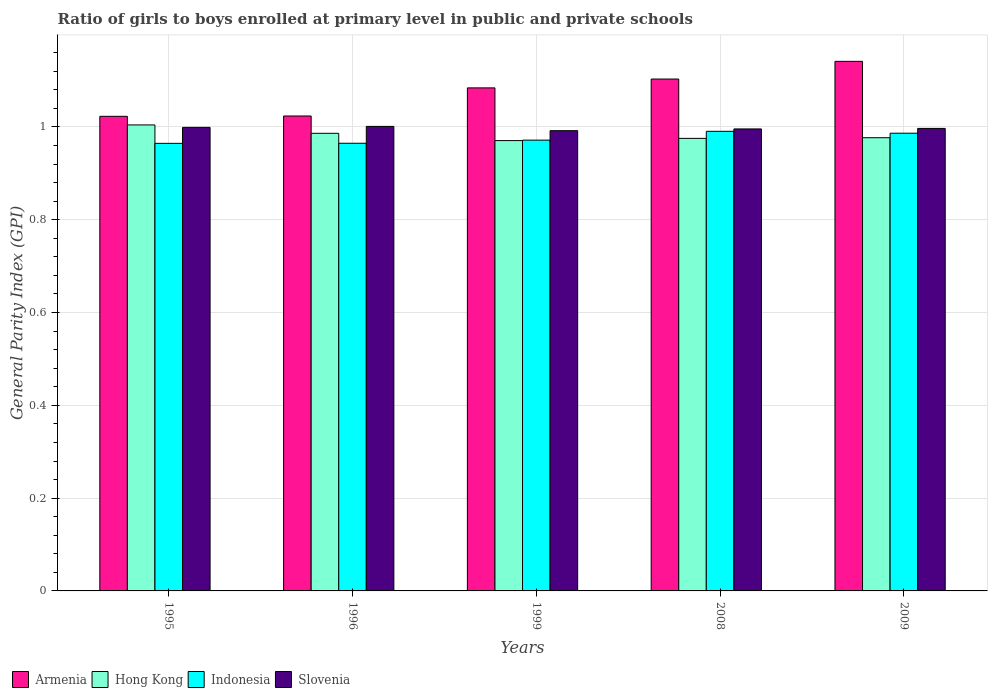How many different coloured bars are there?
Provide a short and direct response. 4. Are the number of bars per tick equal to the number of legend labels?
Your answer should be compact. Yes. How many bars are there on the 2nd tick from the right?
Offer a very short reply. 4. In how many cases, is the number of bars for a given year not equal to the number of legend labels?
Your answer should be very brief. 0. What is the general parity index in Armenia in 1995?
Ensure brevity in your answer.  1.02. Across all years, what is the maximum general parity index in Slovenia?
Make the answer very short. 1. Across all years, what is the minimum general parity index in Armenia?
Your answer should be compact. 1.02. What is the total general parity index in Armenia in the graph?
Keep it short and to the point. 5.38. What is the difference between the general parity index in Slovenia in 1995 and that in 2009?
Offer a very short reply. 0. What is the difference between the general parity index in Slovenia in 2009 and the general parity index in Hong Kong in 1996?
Make the answer very short. 0.01. What is the average general parity index in Slovenia per year?
Make the answer very short. 1. In the year 1995, what is the difference between the general parity index in Hong Kong and general parity index in Armenia?
Your response must be concise. -0.02. What is the ratio of the general parity index in Hong Kong in 1996 to that in 1999?
Make the answer very short. 1.02. Is the difference between the general parity index in Hong Kong in 2008 and 2009 greater than the difference between the general parity index in Armenia in 2008 and 2009?
Your answer should be compact. Yes. What is the difference between the highest and the second highest general parity index in Slovenia?
Your answer should be compact. 0. What is the difference between the highest and the lowest general parity index in Hong Kong?
Provide a succinct answer. 0.03. Is the sum of the general parity index in Indonesia in 1995 and 1996 greater than the maximum general parity index in Hong Kong across all years?
Provide a succinct answer. Yes. What does the 4th bar from the left in 1995 represents?
Your answer should be very brief. Slovenia. How many bars are there?
Keep it short and to the point. 20. How many legend labels are there?
Ensure brevity in your answer.  4. How are the legend labels stacked?
Offer a terse response. Horizontal. What is the title of the graph?
Make the answer very short. Ratio of girls to boys enrolled at primary level in public and private schools. Does "South Asia" appear as one of the legend labels in the graph?
Provide a succinct answer. No. What is the label or title of the X-axis?
Offer a very short reply. Years. What is the label or title of the Y-axis?
Your response must be concise. General Parity Index (GPI). What is the General Parity Index (GPI) in Armenia in 1995?
Offer a terse response. 1.02. What is the General Parity Index (GPI) of Hong Kong in 1995?
Provide a succinct answer. 1. What is the General Parity Index (GPI) in Indonesia in 1995?
Offer a terse response. 0.96. What is the General Parity Index (GPI) of Slovenia in 1995?
Your answer should be very brief. 1. What is the General Parity Index (GPI) in Armenia in 1996?
Make the answer very short. 1.02. What is the General Parity Index (GPI) of Hong Kong in 1996?
Give a very brief answer. 0.99. What is the General Parity Index (GPI) in Indonesia in 1996?
Give a very brief answer. 0.96. What is the General Parity Index (GPI) of Slovenia in 1996?
Your response must be concise. 1. What is the General Parity Index (GPI) in Armenia in 1999?
Keep it short and to the point. 1.08. What is the General Parity Index (GPI) of Hong Kong in 1999?
Provide a succinct answer. 0.97. What is the General Parity Index (GPI) of Indonesia in 1999?
Your response must be concise. 0.97. What is the General Parity Index (GPI) of Slovenia in 1999?
Ensure brevity in your answer.  0.99. What is the General Parity Index (GPI) in Armenia in 2008?
Offer a very short reply. 1.1. What is the General Parity Index (GPI) of Hong Kong in 2008?
Offer a very short reply. 0.98. What is the General Parity Index (GPI) of Indonesia in 2008?
Give a very brief answer. 0.99. What is the General Parity Index (GPI) of Slovenia in 2008?
Keep it short and to the point. 1. What is the General Parity Index (GPI) in Armenia in 2009?
Offer a very short reply. 1.14. What is the General Parity Index (GPI) of Hong Kong in 2009?
Your response must be concise. 0.98. What is the General Parity Index (GPI) in Indonesia in 2009?
Your answer should be compact. 0.99. What is the General Parity Index (GPI) of Slovenia in 2009?
Offer a very short reply. 1. Across all years, what is the maximum General Parity Index (GPI) in Armenia?
Offer a terse response. 1.14. Across all years, what is the maximum General Parity Index (GPI) of Hong Kong?
Give a very brief answer. 1. Across all years, what is the maximum General Parity Index (GPI) of Indonesia?
Provide a succinct answer. 0.99. Across all years, what is the maximum General Parity Index (GPI) in Slovenia?
Offer a very short reply. 1. Across all years, what is the minimum General Parity Index (GPI) in Armenia?
Your answer should be compact. 1.02. Across all years, what is the minimum General Parity Index (GPI) of Hong Kong?
Your answer should be compact. 0.97. Across all years, what is the minimum General Parity Index (GPI) in Indonesia?
Your answer should be compact. 0.96. Across all years, what is the minimum General Parity Index (GPI) of Slovenia?
Provide a succinct answer. 0.99. What is the total General Parity Index (GPI) of Armenia in the graph?
Provide a succinct answer. 5.38. What is the total General Parity Index (GPI) of Hong Kong in the graph?
Offer a terse response. 4.91. What is the total General Parity Index (GPI) in Indonesia in the graph?
Ensure brevity in your answer.  4.88. What is the total General Parity Index (GPI) in Slovenia in the graph?
Your answer should be compact. 4.99. What is the difference between the General Parity Index (GPI) in Armenia in 1995 and that in 1996?
Offer a terse response. -0. What is the difference between the General Parity Index (GPI) in Hong Kong in 1995 and that in 1996?
Provide a succinct answer. 0.02. What is the difference between the General Parity Index (GPI) of Indonesia in 1995 and that in 1996?
Provide a succinct answer. -0. What is the difference between the General Parity Index (GPI) in Slovenia in 1995 and that in 1996?
Provide a succinct answer. -0. What is the difference between the General Parity Index (GPI) in Armenia in 1995 and that in 1999?
Give a very brief answer. -0.06. What is the difference between the General Parity Index (GPI) in Hong Kong in 1995 and that in 1999?
Provide a succinct answer. 0.03. What is the difference between the General Parity Index (GPI) of Indonesia in 1995 and that in 1999?
Your answer should be very brief. -0.01. What is the difference between the General Parity Index (GPI) of Slovenia in 1995 and that in 1999?
Your response must be concise. 0.01. What is the difference between the General Parity Index (GPI) in Armenia in 1995 and that in 2008?
Your response must be concise. -0.08. What is the difference between the General Parity Index (GPI) in Hong Kong in 1995 and that in 2008?
Your answer should be compact. 0.03. What is the difference between the General Parity Index (GPI) in Indonesia in 1995 and that in 2008?
Your answer should be compact. -0.03. What is the difference between the General Parity Index (GPI) of Slovenia in 1995 and that in 2008?
Ensure brevity in your answer.  0. What is the difference between the General Parity Index (GPI) of Armenia in 1995 and that in 2009?
Give a very brief answer. -0.12. What is the difference between the General Parity Index (GPI) of Hong Kong in 1995 and that in 2009?
Offer a very short reply. 0.03. What is the difference between the General Parity Index (GPI) in Indonesia in 1995 and that in 2009?
Give a very brief answer. -0.02. What is the difference between the General Parity Index (GPI) in Slovenia in 1995 and that in 2009?
Give a very brief answer. 0. What is the difference between the General Parity Index (GPI) of Armenia in 1996 and that in 1999?
Keep it short and to the point. -0.06. What is the difference between the General Parity Index (GPI) in Hong Kong in 1996 and that in 1999?
Your answer should be very brief. 0.02. What is the difference between the General Parity Index (GPI) of Indonesia in 1996 and that in 1999?
Your answer should be compact. -0.01. What is the difference between the General Parity Index (GPI) of Slovenia in 1996 and that in 1999?
Offer a terse response. 0.01. What is the difference between the General Parity Index (GPI) in Armenia in 1996 and that in 2008?
Your answer should be very brief. -0.08. What is the difference between the General Parity Index (GPI) in Hong Kong in 1996 and that in 2008?
Keep it short and to the point. 0.01. What is the difference between the General Parity Index (GPI) of Indonesia in 1996 and that in 2008?
Offer a very short reply. -0.03. What is the difference between the General Parity Index (GPI) of Slovenia in 1996 and that in 2008?
Provide a succinct answer. 0.01. What is the difference between the General Parity Index (GPI) of Armenia in 1996 and that in 2009?
Keep it short and to the point. -0.12. What is the difference between the General Parity Index (GPI) in Hong Kong in 1996 and that in 2009?
Your answer should be compact. 0.01. What is the difference between the General Parity Index (GPI) in Indonesia in 1996 and that in 2009?
Your answer should be very brief. -0.02. What is the difference between the General Parity Index (GPI) in Slovenia in 1996 and that in 2009?
Offer a terse response. 0. What is the difference between the General Parity Index (GPI) of Armenia in 1999 and that in 2008?
Ensure brevity in your answer.  -0.02. What is the difference between the General Parity Index (GPI) of Hong Kong in 1999 and that in 2008?
Give a very brief answer. -0. What is the difference between the General Parity Index (GPI) in Indonesia in 1999 and that in 2008?
Your response must be concise. -0.02. What is the difference between the General Parity Index (GPI) of Slovenia in 1999 and that in 2008?
Provide a succinct answer. -0. What is the difference between the General Parity Index (GPI) of Armenia in 1999 and that in 2009?
Offer a terse response. -0.06. What is the difference between the General Parity Index (GPI) of Hong Kong in 1999 and that in 2009?
Your response must be concise. -0.01. What is the difference between the General Parity Index (GPI) of Indonesia in 1999 and that in 2009?
Ensure brevity in your answer.  -0.01. What is the difference between the General Parity Index (GPI) of Slovenia in 1999 and that in 2009?
Your answer should be compact. -0. What is the difference between the General Parity Index (GPI) in Armenia in 2008 and that in 2009?
Provide a short and direct response. -0.04. What is the difference between the General Parity Index (GPI) of Hong Kong in 2008 and that in 2009?
Your answer should be compact. -0. What is the difference between the General Parity Index (GPI) in Indonesia in 2008 and that in 2009?
Provide a short and direct response. 0. What is the difference between the General Parity Index (GPI) of Slovenia in 2008 and that in 2009?
Provide a succinct answer. -0. What is the difference between the General Parity Index (GPI) in Armenia in 1995 and the General Parity Index (GPI) in Hong Kong in 1996?
Offer a very short reply. 0.04. What is the difference between the General Parity Index (GPI) in Armenia in 1995 and the General Parity Index (GPI) in Indonesia in 1996?
Provide a short and direct response. 0.06. What is the difference between the General Parity Index (GPI) in Armenia in 1995 and the General Parity Index (GPI) in Slovenia in 1996?
Ensure brevity in your answer.  0.02. What is the difference between the General Parity Index (GPI) of Hong Kong in 1995 and the General Parity Index (GPI) of Indonesia in 1996?
Keep it short and to the point. 0.04. What is the difference between the General Parity Index (GPI) of Hong Kong in 1995 and the General Parity Index (GPI) of Slovenia in 1996?
Give a very brief answer. 0. What is the difference between the General Parity Index (GPI) in Indonesia in 1995 and the General Parity Index (GPI) in Slovenia in 1996?
Provide a succinct answer. -0.04. What is the difference between the General Parity Index (GPI) in Armenia in 1995 and the General Parity Index (GPI) in Hong Kong in 1999?
Offer a very short reply. 0.05. What is the difference between the General Parity Index (GPI) of Armenia in 1995 and the General Parity Index (GPI) of Indonesia in 1999?
Offer a very short reply. 0.05. What is the difference between the General Parity Index (GPI) of Armenia in 1995 and the General Parity Index (GPI) of Slovenia in 1999?
Provide a short and direct response. 0.03. What is the difference between the General Parity Index (GPI) in Hong Kong in 1995 and the General Parity Index (GPI) in Indonesia in 1999?
Your answer should be compact. 0.03. What is the difference between the General Parity Index (GPI) of Hong Kong in 1995 and the General Parity Index (GPI) of Slovenia in 1999?
Your answer should be very brief. 0.01. What is the difference between the General Parity Index (GPI) of Indonesia in 1995 and the General Parity Index (GPI) of Slovenia in 1999?
Make the answer very short. -0.03. What is the difference between the General Parity Index (GPI) in Armenia in 1995 and the General Parity Index (GPI) in Hong Kong in 2008?
Offer a terse response. 0.05. What is the difference between the General Parity Index (GPI) in Armenia in 1995 and the General Parity Index (GPI) in Indonesia in 2008?
Your answer should be very brief. 0.03. What is the difference between the General Parity Index (GPI) in Armenia in 1995 and the General Parity Index (GPI) in Slovenia in 2008?
Give a very brief answer. 0.03. What is the difference between the General Parity Index (GPI) in Hong Kong in 1995 and the General Parity Index (GPI) in Indonesia in 2008?
Keep it short and to the point. 0.01. What is the difference between the General Parity Index (GPI) in Hong Kong in 1995 and the General Parity Index (GPI) in Slovenia in 2008?
Make the answer very short. 0.01. What is the difference between the General Parity Index (GPI) in Indonesia in 1995 and the General Parity Index (GPI) in Slovenia in 2008?
Make the answer very short. -0.03. What is the difference between the General Parity Index (GPI) in Armenia in 1995 and the General Parity Index (GPI) in Hong Kong in 2009?
Provide a succinct answer. 0.05. What is the difference between the General Parity Index (GPI) of Armenia in 1995 and the General Parity Index (GPI) of Indonesia in 2009?
Offer a very short reply. 0.04. What is the difference between the General Parity Index (GPI) of Armenia in 1995 and the General Parity Index (GPI) of Slovenia in 2009?
Offer a terse response. 0.03. What is the difference between the General Parity Index (GPI) in Hong Kong in 1995 and the General Parity Index (GPI) in Indonesia in 2009?
Provide a succinct answer. 0.02. What is the difference between the General Parity Index (GPI) of Hong Kong in 1995 and the General Parity Index (GPI) of Slovenia in 2009?
Provide a short and direct response. 0.01. What is the difference between the General Parity Index (GPI) of Indonesia in 1995 and the General Parity Index (GPI) of Slovenia in 2009?
Keep it short and to the point. -0.03. What is the difference between the General Parity Index (GPI) of Armenia in 1996 and the General Parity Index (GPI) of Hong Kong in 1999?
Ensure brevity in your answer.  0.05. What is the difference between the General Parity Index (GPI) of Armenia in 1996 and the General Parity Index (GPI) of Indonesia in 1999?
Give a very brief answer. 0.05. What is the difference between the General Parity Index (GPI) in Armenia in 1996 and the General Parity Index (GPI) in Slovenia in 1999?
Keep it short and to the point. 0.03. What is the difference between the General Parity Index (GPI) in Hong Kong in 1996 and the General Parity Index (GPI) in Indonesia in 1999?
Make the answer very short. 0.01. What is the difference between the General Parity Index (GPI) in Hong Kong in 1996 and the General Parity Index (GPI) in Slovenia in 1999?
Provide a short and direct response. -0.01. What is the difference between the General Parity Index (GPI) of Indonesia in 1996 and the General Parity Index (GPI) of Slovenia in 1999?
Your answer should be very brief. -0.03. What is the difference between the General Parity Index (GPI) of Armenia in 1996 and the General Parity Index (GPI) of Hong Kong in 2008?
Ensure brevity in your answer.  0.05. What is the difference between the General Parity Index (GPI) in Armenia in 1996 and the General Parity Index (GPI) in Indonesia in 2008?
Offer a terse response. 0.03. What is the difference between the General Parity Index (GPI) of Armenia in 1996 and the General Parity Index (GPI) of Slovenia in 2008?
Give a very brief answer. 0.03. What is the difference between the General Parity Index (GPI) in Hong Kong in 1996 and the General Parity Index (GPI) in Indonesia in 2008?
Provide a short and direct response. -0. What is the difference between the General Parity Index (GPI) in Hong Kong in 1996 and the General Parity Index (GPI) in Slovenia in 2008?
Offer a terse response. -0.01. What is the difference between the General Parity Index (GPI) of Indonesia in 1996 and the General Parity Index (GPI) of Slovenia in 2008?
Give a very brief answer. -0.03. What is the difference between the General Parity Index (GPI) of Armenia in 1996 and the General Parity Index (GPI) of Hong Kong in 2009?
Offer a terse response. 0.05. What is the difference between the General Parity Index (GPI) in Armenia in 1996 and the General Parity Index (GPI) in Indonesia in 2009?
Your response must be concise. 0.04. What is the difference between the General Parity Index (GPI) in Armenia in 1996 and the General Parity Index (GPI) in Slovenia in 2009?
Provide a succinct answer. 0.03. What is the difference between the General Parity Index (GPI) in Hong Kong in 1996 and the General Parity Index (GPI) in Indonesia in 2009?
Give a very brief answer. -0. What is the difference between the General Parity Index (GPI) in Hong Kong in 1996 and the General Parity Index (GPI) in Slovenia in 2009?
Provide a succinct answer. -0.01. What is the difference between the General Parity Index (GPI) in Indonesia in 1996 and the General Parity Index (GPI) in Slovenia in 2009?
Your response must be concise. -0.03. What is the difference between the General Parity Index (GPI) in Armenia in 1999 and the General Parity Index (GPI) in Hong Kong in 2008?
Your answer should be very brief. 0.11. What is the difference between the General Parity Index (GPI) of Armenia in 1999 and the General Parity Index (GPI) of Indonesia in 2008?
Provide a short and direct response. 0.09. What is the difference between the General Parity Index (GPI) of Armenia in 1999 and the General Parity Index (GPI) of Slovenia in 2008?
Your answer should be compact. 0.09. What is the difference between the General Parity Index (GPI) of Hong Kong in 1999 and the General Parity Index (GPI) of Indonesia in 2008?
Your answer should be compact. -0.02. What is the difference between the General Parity Index (GPI) of Hong Kong in 1999 and the General Parity Index (GPI) of Slovenia in 2008?
Your answer should be very brief. -0.03. What is the difference between the General Parity Index (GPI) in Indonesia in 1999 and the General Parity Index (GPI) in Slovenia in 2008?
Offer a very short reply. -0.02. What is the difference between the General Parity Index (GPI) in Armenia in 1999 and the General Parity Index (GPI) in Hong Kong in 2009?
Offer a very short reply. 0.11. What is the difference between the General Parity Index (GPI) of Armenia in 1999 and the General Parity Index (GPI) of Indonesia in 2009?
Ensure brevity in your answer.  0.1. What is the difference between the General Parity Index (GPI) in Armenia in 1999 and the General Parity Index (GPI) in Slovenia in 2009?
Provide a succinct answer. 0.09. What is the difference between the General Parity Index (GPI) of Hong Kong in 1999 and the General Parity Index (GPI) of Indonesia in 2009?
Your answer should be compact. -0.02. What is the difference between the General Parity Index (GPI) in Hong Kong in 1999 and the General Parity Index (GPI) in Slovenia in 2009?
Offer a terse response. -0.03. What is the difference between the General Parity Index (GPI) of Indonesia in 1999 and the General Parity Index (GPI) of Slovenia in 2009?
Provide a succinct answer. -0.03. What is the difference between the General Parity Index (GPI) in Armenia in 2008 and the General Parity Index (GPI) in Hong Kong in 2009?
Provide a succinct answer. 0.13. What is the difference between the General Parity Index (GPI) in Armenia in 2008 and the General Parity Index (GPI) in Indonesia in 2009?
Your answer should be compact. 0.12. What is the difference between the General Parity Index (GPI) of Armenia in 2008 and the General Parity Index (GPI) of Slovenia in 2009?
Offer a very short reply. 0.11. What is the difference between the General Parity Index (GPI) in Hong Kong in 2008 and the General Parity Index (GPI) in Indonesia in 2009?
Offer a very short reply. -0.01. What is the difference between the General Parity Index (GPI) of Hong Kong in 2008 and the General Parity Index (GPI) of Slovenia in 2009?
Ensure brevity in your answer.  -0.02. What is the difference between the General Parity Index (GPI) in Indonesia in 2008 and the General Parity Index (GPI) in Slovenia in 2009?
Provide a succinct answer. -0.01. What is the average General Parity Index (GPI) in Armenia per year?
Give a very brief answer. 1.08. What is the average General Parity Index (GPI) of Hong Kong per year?
Offer a very short reply. 0.98. What is the average General Parity Index (GPI) in Indonesia per year?
Give a very brief answer. 0.98. In the year 1995, what is the difference between the General Parity Index (GPI) in Armenia and General Parity Index (GPI) in Hong Kong?
Ensure brevity in your answer.  0.02. In the year 1995, what is the difference between the General Parity Index (GPI) in Armenia and General Parity Index (GPI) in Indonesia?
Ensure brevity in your answer.  0.06. In the year 1995, what is the difference between the General Parity Index (GPI) in Armenia and General Parity Index (GPI) in Slovenia?
Make the answer very short. 0.02. In the year 1995, what is the difference between the General Parity Index (GPI) in Hong Kong and General Parity Index (GPI) in Indonesia?
Your answer should be very brief. 0.04. In the year 1995, what is the difference between the General Parity Index (GPI) of Hong Kong and General Parity Index (GPI) of Slovenia?
Your answer should be compact. 0.01. In the year 1995, what is the difference between the General Parity Index (GPI) in Indonesia and General Parity Index (GPI) in Slovenia?
Keep it short and to the point. -0.03. In the year 1996, what is the difference between the General Parity Index (GPI) in Armenia and General Parity Index (GPI) in Hong Kong?
Provide a succinct answer. 0.04. In the year 1996, what is the difference between the General Parity Index (GPI) of Armenia and General Parity Index (GPI) of Indonesia?
Your response must be concise. 0.06. In the year 1996, what is the difference between the General Parity Index (GPI) in Armenia and General Parity Index (GPI) in Slovenia?
Give a very brief answer. 0.02. In the year 1996, what is the difference between the General Parity Index (GPI) in Hong Kong and General Parity Index (GPI) in Indonesia?
Provide a short and direct response. 0.02. In the year 1996, what is the difference between the General Parity Index (GPI) of Hong Kong and General Parity Index (GPI) of Slovenia?
Your answer should be compact. -0.01. In the year 1996, what is the difference between the General Parity Index (GPI) in Indonesia and General Parity Index (GPI) in Slovenia?
Ensure brevity in your answer.  -0.04. In the year 1999, what is the difference between the General Parity Index (GPI) in Armenia and General Parity Index (GPI) in Hong Kong?
Offer a very short reply. 0.11. In the year 1999, what is the difference between the General Parity Index (GPI) in Armenia and General Parity Index (GPI) in Indonesia?
Give a very brief answer. 0.11. In the year 1999, what is the difference between the General Parity Index (GPI) of Armenia and General Parity Index (GPI) of Slovenia?
Give a very brief answer. 0.09. In the year 1999, what is the difference between the General Parity Index (GPI) in Hong Kong and General Parity Index (GPI) in Indonesia?
Keep it short and to the point. -0. In the year 1999, what is the difference between the General Parity Index (GPI) of Hong Kong and General Parity Index (GPI) of Slovenia?
Provide a succinct answer. -0.02. In the year 1999, what is the difference between the General Parity Index (GPI) of Indonesia and General Parity Index (GPI) of Slovenia?
Ensure brevity in your answer.  -0.02. In the year 2008, what is the difference between the General Parity Index (GPI) of Armenia and General Parity Index (GPI) of Hong Kong?
Offer a very short reply. 0.13. In the year 2008, what is the difference between the General Parity Index (GPI) in Armenia and General Parity Index (GPI) in Indonesia?
Make the answer very short. 0.11. In the year 2008, what is the difference between the General Parity Index (GPI) of Armenia and General Parity Index (GPI) of Slovenia?
Your answer should be compact. 0.11. In the year 2008, what is the difference between the General Parity Index (GPI) of Hong Kong and General Parity Index (GPI) of Indonesia?
Give a very brief answer. -0.02. In the year 2008, what is the difference between the General Parity Index (GPI) in Hong Kong and General Parity Index (GPI) in Slovenia?
Give a very brief answer. -0.02. In the year 2008, what is the difference between the General Parity Index (GPI) of Indonesia and General Parity Index (GPI) of Slovenia?
Make the answer very short. -0.01. In the year 2009, what is the difference between the General Parity Index (GPI) of Armenia and General Parity Index (GPI) of Hong Kong?
Provide a succinct answer. 0.16. In the year 2009, what is the difference between the General Parity Index (GPI) of Armenia and General Parity Index (GPI) of Indonesia?
Give a very brief answer. 0.15. In the year 2009, what is the difference between the General Parity Index (GPI) of Armenia and General Parity Index (GPI) of Slovenia?
Your answer should be very brief. 0.14. In the year 2009, what is the difference between the General Parity Index (GPI) of Hong Kong and General Parity Index (GPI) of Indonesia?
Keep it short and to the point. -0.01. In the year 2009, what is the difference between the General Parity Index (GPI) of Hong Kong and General Parity Index (GPI) of Slovenia?
Provide a short and direct response. -0.02. In the year 2009, what is the difference between the General Parity Index (GPI) of Indonesia and General Parity Index (GPI) of Slovenia?
Make the answer very short. -0.01. What is the ratio of the General Parity Index (GPI) in Armenia in 1995 to that in 1996?
Keep it short and to the point. 1. What is the ratio of the General Parity Index (GPI) in Hong Kong in 1995 to that in 1996?
Offer a terse response. 1.02. What is the ratio of the General Parity Index (GPI) in Slovenia in 1995 to that in 1996?
Give a very brief answer. 1. What is the ratio of the General Parity Index (GPI) of Armenia in 1995 to that in 1999?
Your answer should be very brief. 0.94. What is the ratio of the General Parity Index (GPI) of Hong Kong in 1995 to that in 1999?
Provide a short and direct response. 1.03. What is the ratio of the General Parity Index (GPI) in Armenia in 1995 to that in 2008?
Your response must be concise. 0.93. What is the ratio of the General Parity Index (GPI) in Hong Kong in 1995 to that in 2008?
Provide a succinct answer. 1.03. What is the ratio of the General Parity Index (GPI) of Indonesia in 1995 to that in 2008?
Your response must be concise. 0.97. What is the ratio of the General Parity Index (GPI) in Armenia in 1995 to that in 2009?
Make the answer very short. 0.9. What is the ratio of the General Parity Index (GPI) in Hong Kong in 1995 to that in 2009?
Your answer should be very brief. 1.03. What is the ratio of the General Parity Index (GPI) of Indonesia in 1995 to that in 2009?
Your answer should be very brief. 0.98. What is the ratio of the General Parity Index (GPI) of Slovenia in 1995 to that in 2009?
Ensure brevity in your answer.  1. What is the ratio of the General Parity Index (GPI) of Armenia in 1996 to that in 1999?
Your answer should be compact. 0.94. What is the ratio of the General Parity Index (GPI) of Hong Kong in 1996 to that in 1999?
Provide a short and direct response. 1.02. What is the ratio of the General Parity Index (GPI) of Slovenia in 1996 to that in 1999?
Give a very brief answer. 1.01. What is the ratio of the General Parity Index (GPI) in Armenia in 1996 to that in 2008?
Ensure brevity in your answer.  0.93. What is the ratio of the General Parity Index (GPI) in Hong Kong in 1996 to that in 2008?
Offer a terse response. 1.01. What is the ratio of the General Parity Index (GPI) of Indonesia in 1996 to that in 2008?
Your answer should be compact. 0.97. What is the ratio of the General Parity Index (GPI) in Armenia in 1996 to that in 2009?
Make the answer very short. 0.9. What is the ratio of the General Parity Index (GPI) in Hong Kong in 1996 to that in 2009?
Ensure brevity in your answer.  1.01. What is the ratio of the General Parity Index (GPI) of Armenia in 1999 to that in 2008?
Provide a short and direct response. 0.98. What is the ratio of the General Parity Index (GPI) of Indonesia in 1999 to that in 2008?
Provide a short and direct response. 0.98. What is the ratio of the General Parity Index (GPI) of Armenia in 1999 to that in 2009?
Ensure brevity in your answer.  0.95. What is the ratio of the General Parity Index (GPI) of Hong Kong in 1999 to that in 2009?
Give a very brief answer. 0.99. What is the ratio of the General Parity Index (GPI) in Indonesia in 1999 to that in 2009?
Ensure brevity in your answer.  0.98. What is the ratio of the General Parity Index (GPI) of Slovenia in 1999 to that in 2009?
Make the answer very short. 1. What is the ratio of the General Parity Index (GPI) of Armenia in 2008 to that in 2009?
Provide a succinct answer. 0.97. What is the ratio of the General Parity Index (GPI) in Hong Kong in 2008 to that in 2009?
Offer a very short reply. 1. What is the ratio of the General Parity Index (GPI) in Slovenia in 2008 to that in 2009?
Your answer should be very brief. 1. What is the difference between the highest and the second highest General Parity Index (GPI) in Armenia?
Keep it short and to the point. 0.04. What is the difference between the highest and the second highest General Parity Index (GPI) in Hong Kong?
Offer a very short reply. 0.02. What is the difference between the highest and the second highest General Parity Index (GPI) in Indonesia?
Give a very brief answer. 0. What is the difference between the highest and the second highest General Parity Index (GPI) of Slovenia?
Your response must be concise. 0. What is the difference between the highest and the lowest General Parity Index (GPI) in Armenia?
Make the answer very short. 0.12. What is the difference between the highest and the lowest General Parity Index (GPI) in Hong Kong?
Your answer should be compact. 0.03. What is the difference between the highest and the lowest General Parity Index (GPI) of Indonesia?
Provide a succinct answer. 0.03. What is the difference between the highest and the lowest General Parity Index (GPI) of Slovenia?
Keep it short and to the point. 0.01. 